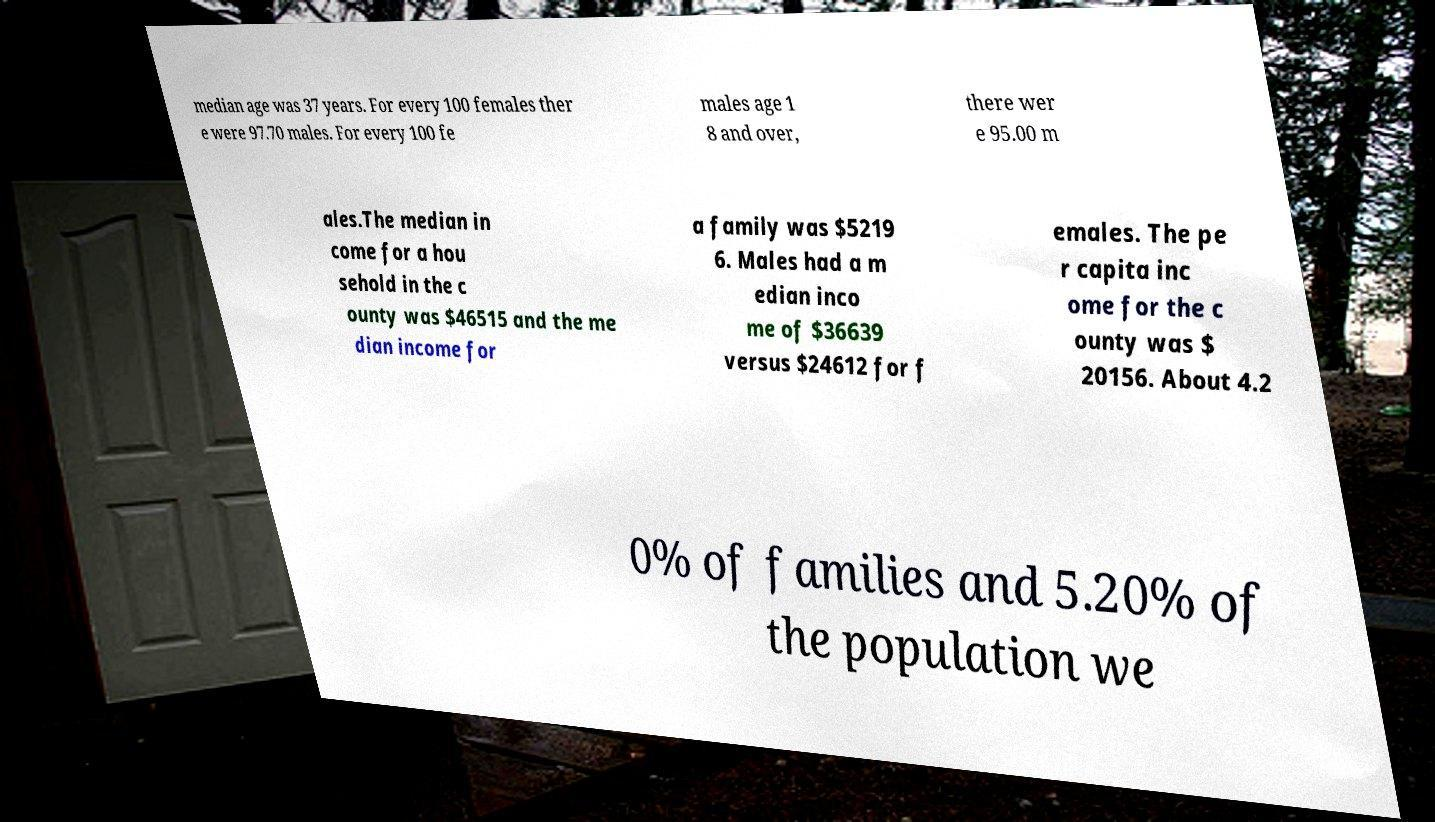Can you read and provide the text displayed in the image?This photo seems to have some interesting text. Can you extract and type it out for me? median age was 37 years. For every 100 females ther e were 97.70 males. For every 100 fe males age 1 8 and over, there wer e 95.00 m ales.The median in come for a hou sehold in the c ounty was $46515 and the me dian income for a family was $5219 6. Males had a m edian inco me of $36639 versus $24612 for f emales. The pe r capita inc ome for the c ounty was $ 20156. About 4.2 0% of families and 5.20% of the population we 